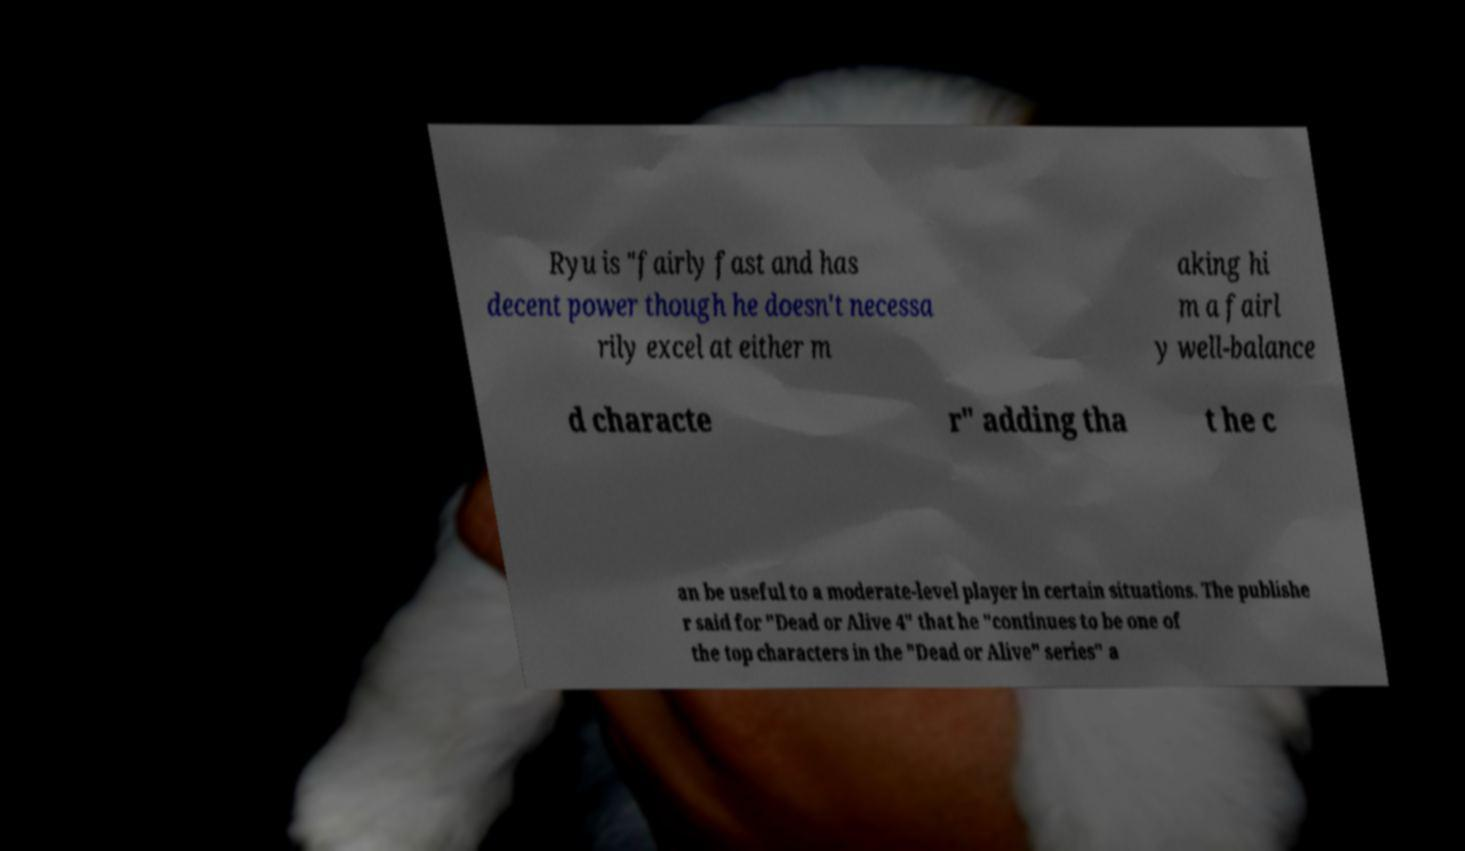Can you read and provide the text displayed in the image?This photo seems to have some interesting text. Can you extract and type it out for me? Ryu is "fairly fast and has decent power though he doesn't necessa rily excel at either m aking hi m a fairl y well-balance d characte r" adding tha t he c an be useful to a moderate-level player in certain situations. The publishe r said for "Dead or Alive 4" that he "continues to be one of the top characters in the "Dead or Alive" series" a 